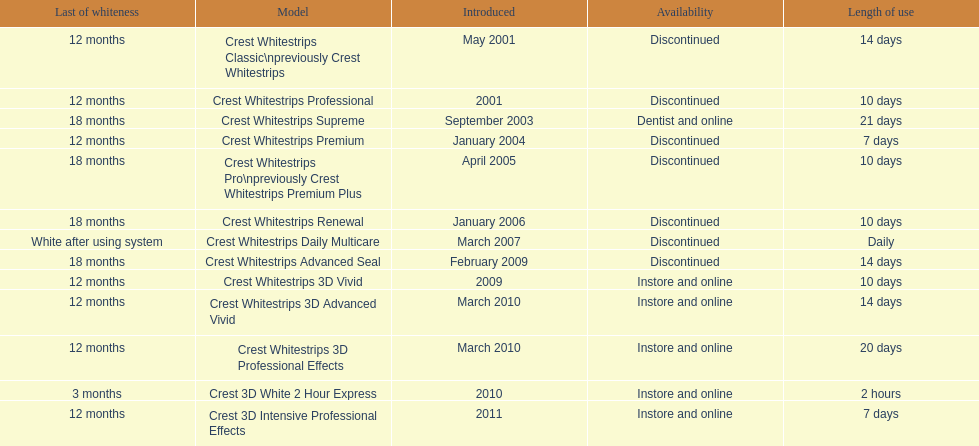Crest 3d intensive professional effects and crest whitestrips 3d professional effects both have a lasting whiteness of how many months? 12 months. 